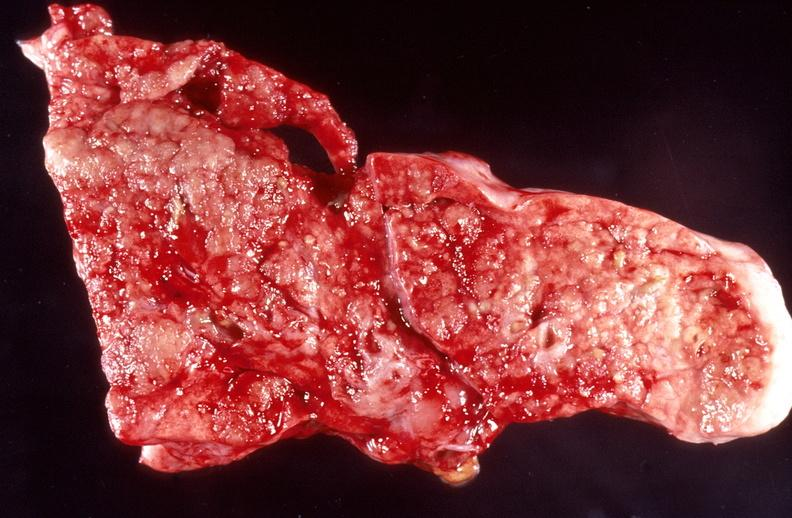does retroperitoneal liposarcoma show lung, bronchopneumonia, cystic fibrosis?
Answer the question using a single word or phrase. No 